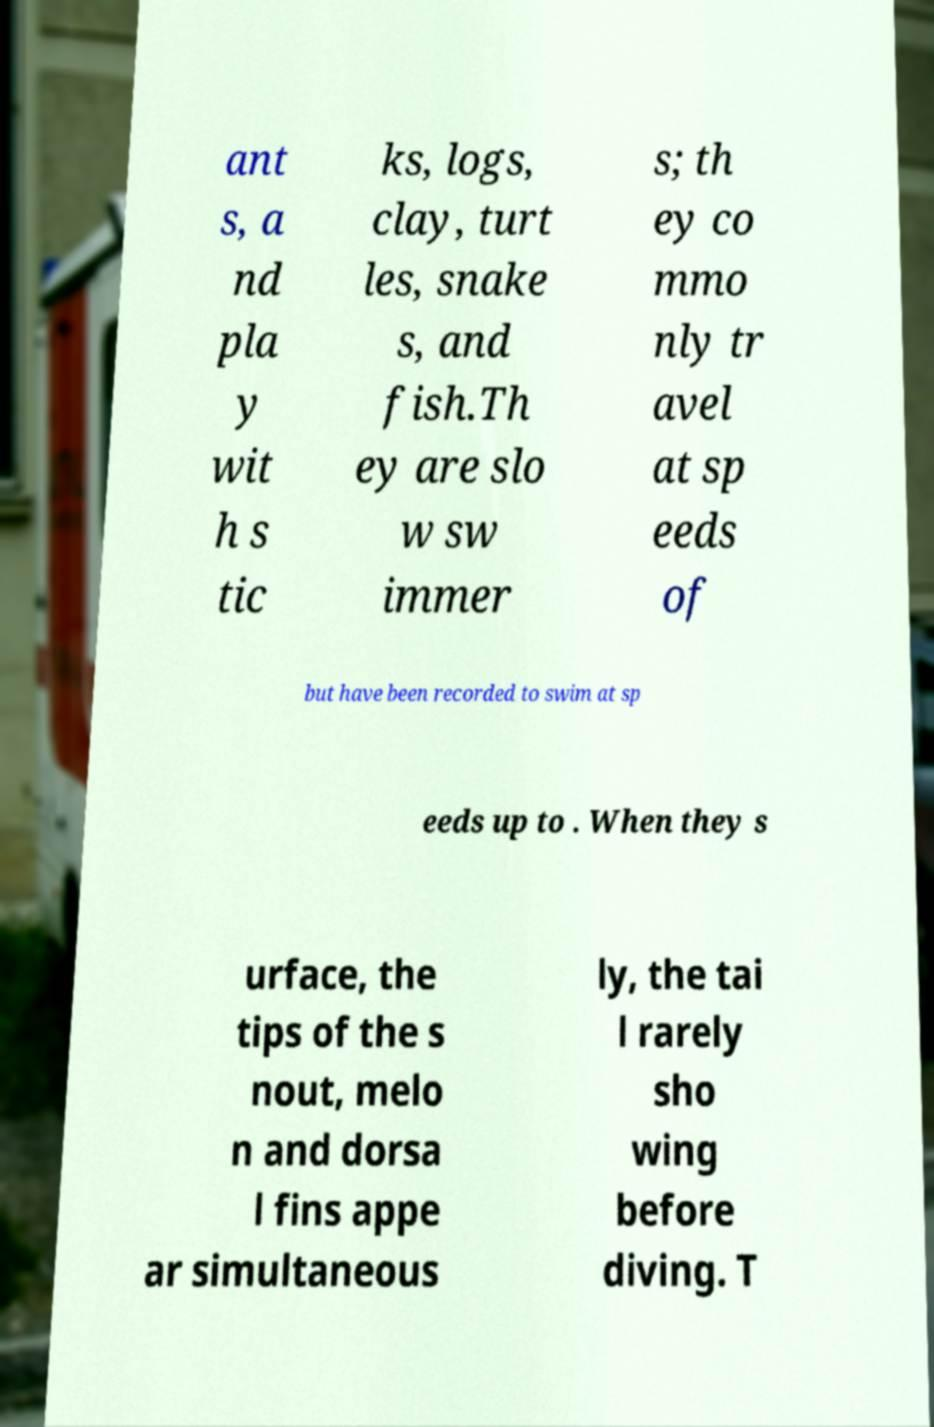Could you assist in decoding the text presented in this image and type it out clearly? ant s, a nd pla y wit h s tic ks, logs, clay, turt les, snake s, and fish.Th ey are slo w sw immer s; th ey co mmo nly tr avel at sp eeds of but have been recorded to swim at sp eeds up to . When they s urface, the tips of the s nout, melo n and dorsa l fins appe ar simultaneous ly, the tai l rarely sho wing before diving. T 